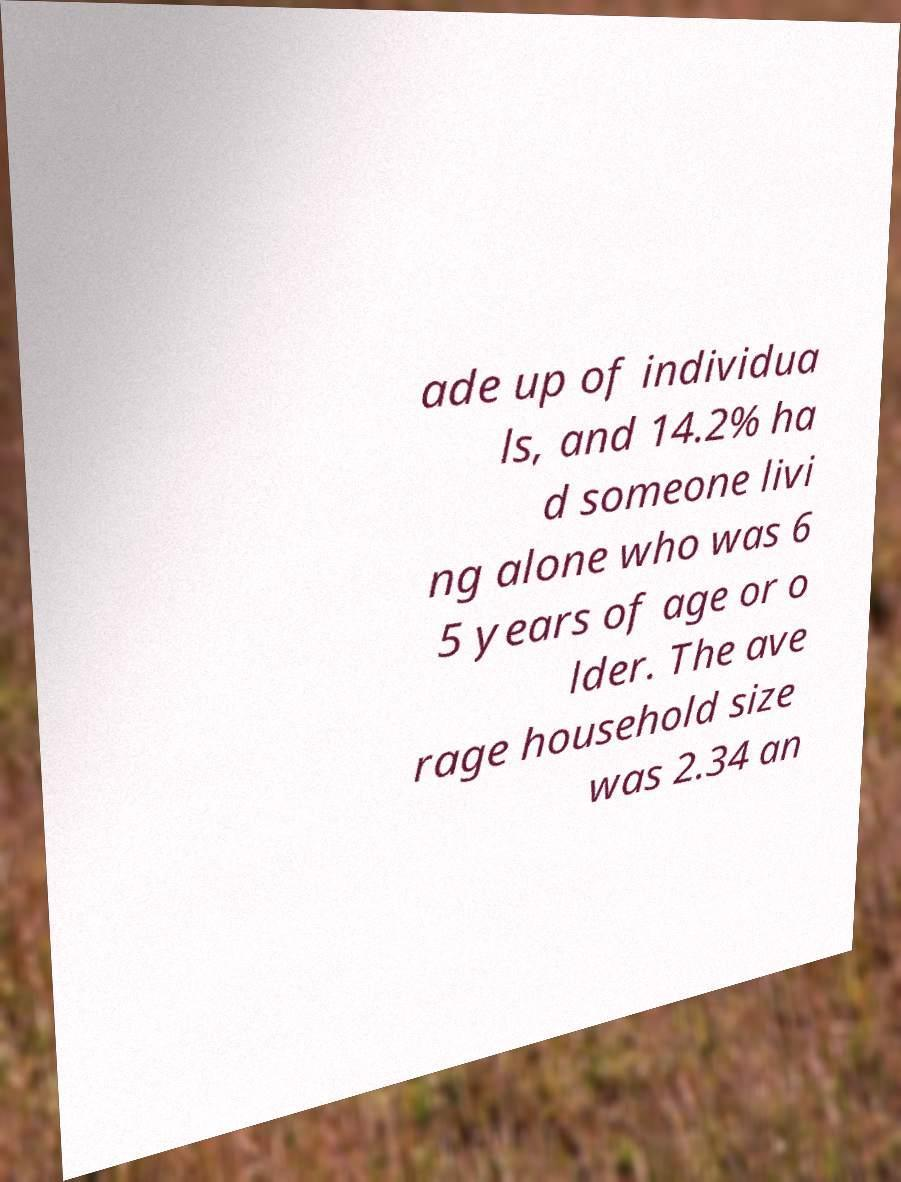I need the written content from this picture converted into text. Can you do that? ade up of individua ls, and 14.2% ha d someone livi ng alone who was 6 5 years of age or o lder. The ave rage household size was 2.34 an 